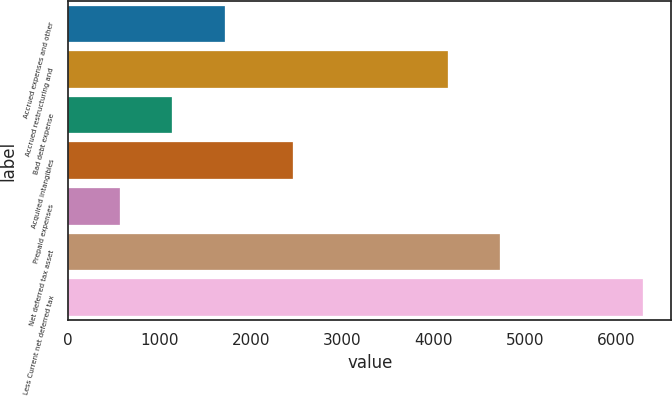Convert chart to OTSL. <chart><loc_0><loc_0><loc_500><loc_500><bar_chart><fcel>Accrued expenses and other<fcel>Accrued restructuring and<fcel>Bad debt expense<fcel>Acquired intangibles<fcel>Prepaid expenses<fcel>Net deferred tax asset<fcel>Less Current net deferred tax<nl><fcel>1713<fcel>4159<fcel>1141<fcel>2457<fcel>569<fcel>4731<fcel>6289<nl></chart> 